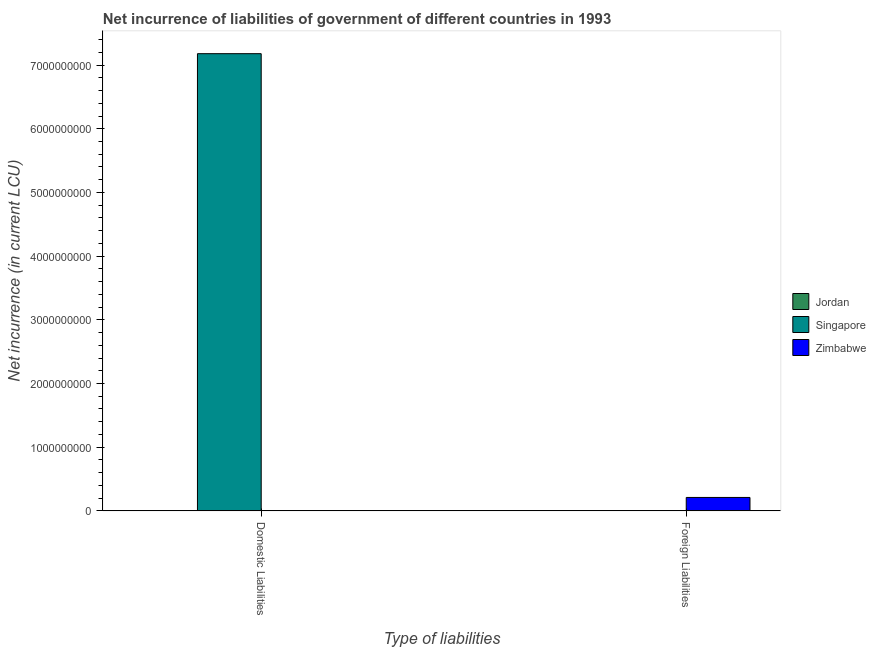How many different coloured bars are there?
Offer a very short reply. 3. Are the number of bars per tick equal to the number of legend labels?
Your response must be concise. No. How many bars are there on the 2nd tick from the left?
Keep it short and to the point. 1. What is the label of the 2nd group of bars from the left?
Your response must be concise. Foreign Liabilities. What is the net incurrence of domestic liabilities in Jordan?
Give a very brief answer. 9.30e+05. Across all countries, what is the maximum net incurrence of foreign liabilities?
Provide a short and direct response. 2.11e+08. Across all countries, what is the minimum net incurrence of domestic liabilities?
Offer a very short reply. 0. In which country was the net incurrence of foreign liabilities maximum?
Offer a very short reply. Zimbabwe. What is the total net incurrence of domestic liabilities in the graph?
Offer a very short reply. 7.18e+09. What is the difference between the net incurrence of domestic liabilities in Jordan and that in Singapore?
Provide a short and direct response. -7.18e+09. What is the difference between the net incurrence of foreign liabilities in Zimbabwe and the net incurrence of domestic liabilities in Singapore?
Your answer should be very brief. -6.97e+09. What is the average net incurrence of domestic liabilities per country?
Your answer should be compact. 2.39e+09. In how many countries, is the net incurrence of foreign liabilities greater than 400000000 LCU?
Make the answer very short. 0. Are all the bars in the graph horizontal?
Your answer should be compact. No. Are the values on the major ticks of Y-axis written in scientific E-notation?
Keep it short and to the point. No. Does the graph contain grids?
Offer a very short reply. No. How many legend labels are there?
Give a very brief answer. 3. How are the legend labels stacked?
Offer a terse response. Vertical. What is the title of the graph?
Offer a terse response. Net incurrence of liabilities of government of different countries in 1993. Does "Seychelles" appear as one of the legend labels in the graph?
Provide a succinct answer. No. What is the label or title of the X-axis?
Your answer should be compact. Type of liabilities. What is the label or title of the Y-axis?
Give a very brief answer. Net incurrence (in current LCU). What is the Net incurrence (in current LCU) in Jordan in Domestic Liabilities?
Give a very brief answer. 9.30e+05. What is the Net incurrence (in current LCU) in Singapore in Domestic Liabilities?
Provide a short and direct response. 7.18e+09. What is the Net incurrence (in current LCU) in Singapore in Foreign Liabilities?
Provide a succinct answer. 0. What is the Net incurrence (in current LCU) of Zimbabwe in Foreign Liabilities?
Ensure brevity in your answer.  2.11e+08. Across all Type of liabilities, what is the maximum Net incurrence (in current LCU) in Jordan?
Make the answer very short. 9.30e+05. Across all Type of liabilities, what is the maximum Net incurrence (in current LCU) of Singapore?
Keep it short and to the point. 7.18e+09. Across all Type of liabilities, what is the maximum Net incurrence (in current LCU) in Zimbabwe?
Provide a succinct answer. 2.11e+08. Across all Type of liabilities, what is the minimum Net incurrence (in current LCU) of Singapore?
Ensure brevity in your answer.  0. Across all Type of liabilities, what is the minimum Net incurrence (in current LCU) of Zimbabwe?
Ensure brevity in your answer.  0. What is the total Net incurrence (in current LCU) in Jordan in the graph?
Make the answer very short. 9.30e+05. What is the total Net incurrence (in current LCU) in Singapore in the graph?
Keep it short and to the point. 7.18e+09. What is the total Net incurrence (in current LCU) in Zimbabwe in the graph?
Your answer should be very brief. 2.11e+08. What is the difference between the Net incurrence (in current LCU) of Jordan in Domestic Liabilities and the Net incurrence (in current LCU) of Zimbabwe in Foreign Liabilities?
Provide a succinct answer. -2.10e+08. What is the difference between the Net incurrence (in current LCU) of Singapore in Domestic Liabilities and the Net incurrence (in current LCU) of Zimbabwe in Foreign Liabilities?
Your answer should be very brief. 6.97e+09. What is the average Net incurrence (in current LCU) of Jordan per Type of liabilities?
Your answer should be very brief. 4.65e+05. What is the average Net incurrence (in current LCU) in Singapore per Type of liabilities?
Ensure brevity in your answer.  3.59e+09. What is the average Net incurrence (in current LCU) in Zimbabwe per Type of liabilities?
Ensure brevity in your answer.  1.06e+08. What is the difference between the Net incurrence (in current LCU) in Jordan and Net incurrence (in current LCU) in Singapore in Domestic Liabilities?
Ensure brevity in your answer.  -7.18e+09. What is the difference between the highest and the lowest Net incurrence (in current LCU) in Jordan?
Offer a terse response. 9.30e+05. What is the difference between the highest and the lowest Net incurrence (in current LCU) of Singapore?
Provide a succinct answer. 7.18e+09. What is the difference between the highest and the lowest Net incurrence (in current LCU) of Zimbabwe?
Your answer should be very brief. 2.11e+08. 